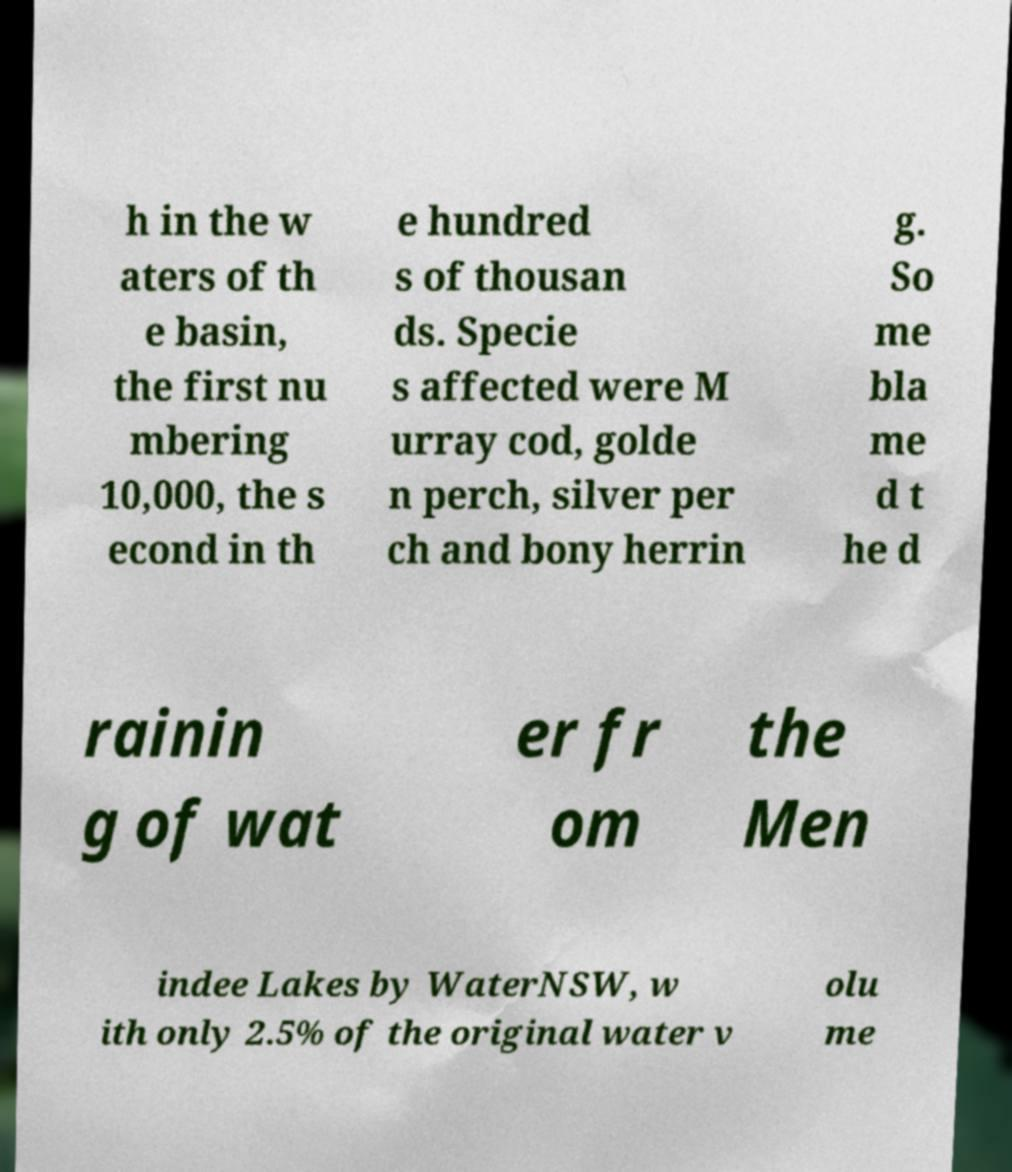What messages or text are displayed in this image? I need them in a readable, typed format. h in the w aters of th e basin, the first nu mbering 10,000, the s econd in th e hundred s of thousan ds. Specie s affected were M urray cod, golde n perch, silver per ch and bony herrin g. So me bla me d t he d rainin g of wat er fr om the Men indee Lakes by WaterNSW, w ith only 2.5% of the original water v olu me 